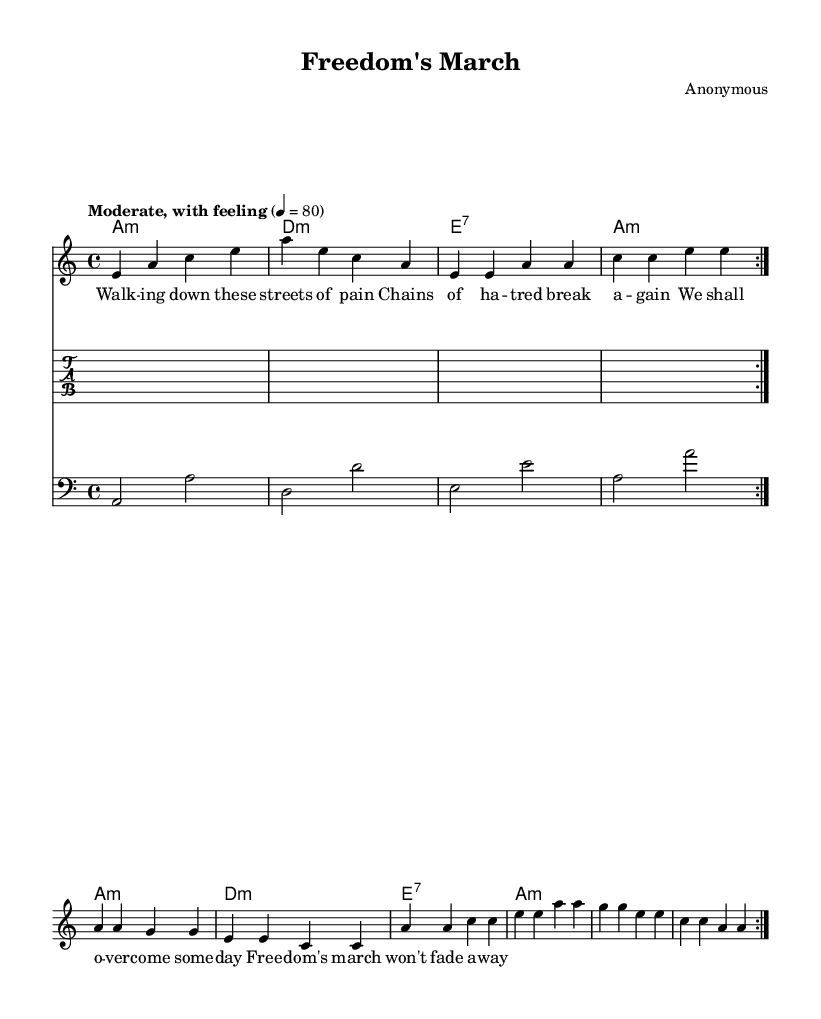What is the key signature of this music? The key signature provided in the music is A minor, indicated by the key signature that has no sharps or flats, as A minor is the relative minor of C major.
Answer: A minor What is the time signature of this music? The time signature is shown at the beginning of the music as 4/4, meaning there are four beats in each measure and a quarter note receives one beat.
Answer: 4/4 What is the tempo marking of this music? The tempo marking states "Moderate, with feeling" and is set to a speed of quarter note equals 80 beats per minute, indicating a moderate pace.
Answer: 80 How many measures are there in the repeated section? The repeated section consists of two measures, as indicated by the repeat sign and the structure of the melody in the given music.
Answer: 2 What is the chord progression for the first four measures? The chord progression for the first four measures alternates between A minor, D minor, E7, and A minor, which is typical in blues music and provides a harmonic foundation.
Answer: A minor, D minor, E7, A minor What lyrical theme does this piece represent? The lyrics contain themes of struggle and hope related to freedom, indicating a connection to the social change movements of the 1960s, reflecting the spirit of the Civil Rights Movement.
Answer: Freedom and struggle 